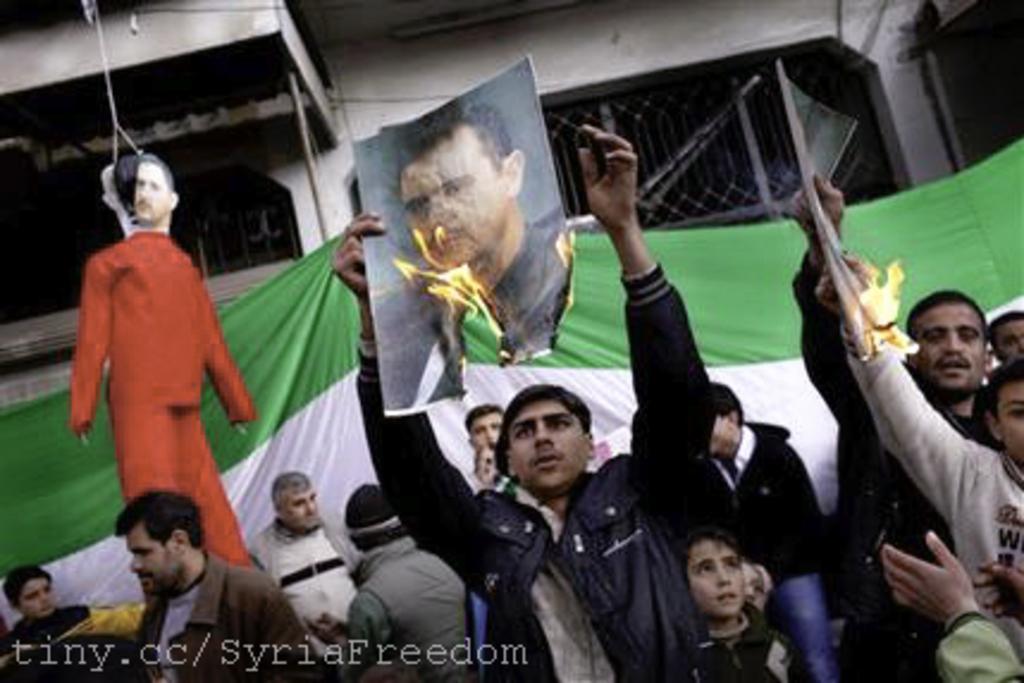Describe this image in one or two sentences. In the image there are a group of people in the foreground, they are burning the photos of some people and in the background there is a flag and behind the flag there are two windows in between the wall. 